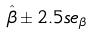<formula> <loc_0><loc_0><loc_500><loc_500>\hat { \beta } \pm 2 . 5 s e _ { \beta }</formula> 